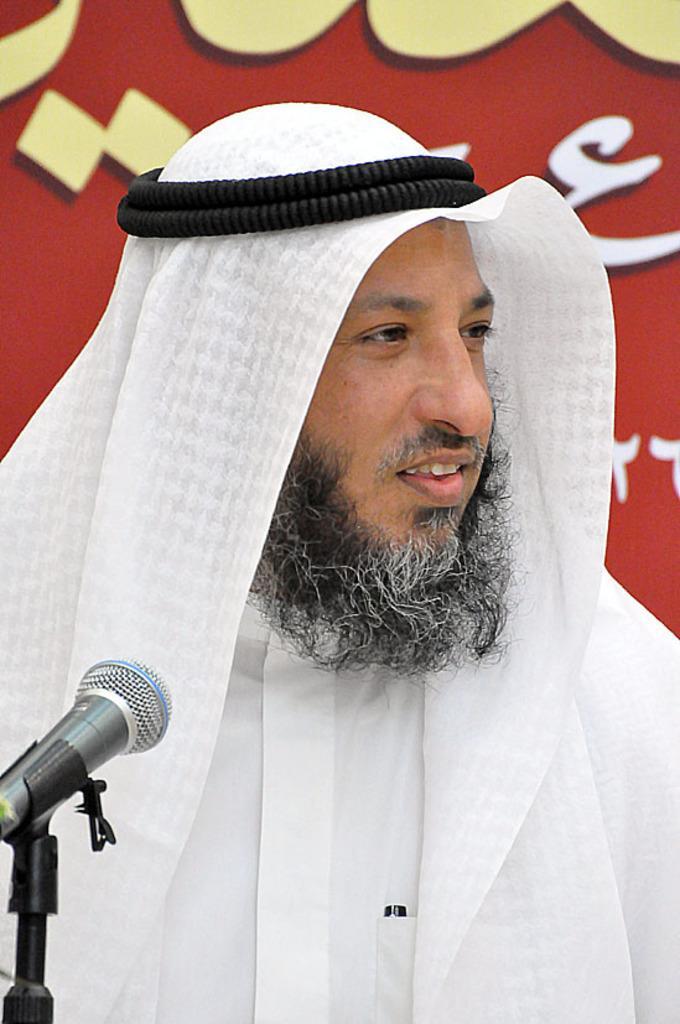Describe this image in one or two sentences. There is a person wearing a white scarf on the head with black color round thing. In the back there is a red wall with something written on that. In front of him there is a mic with mic stand. 